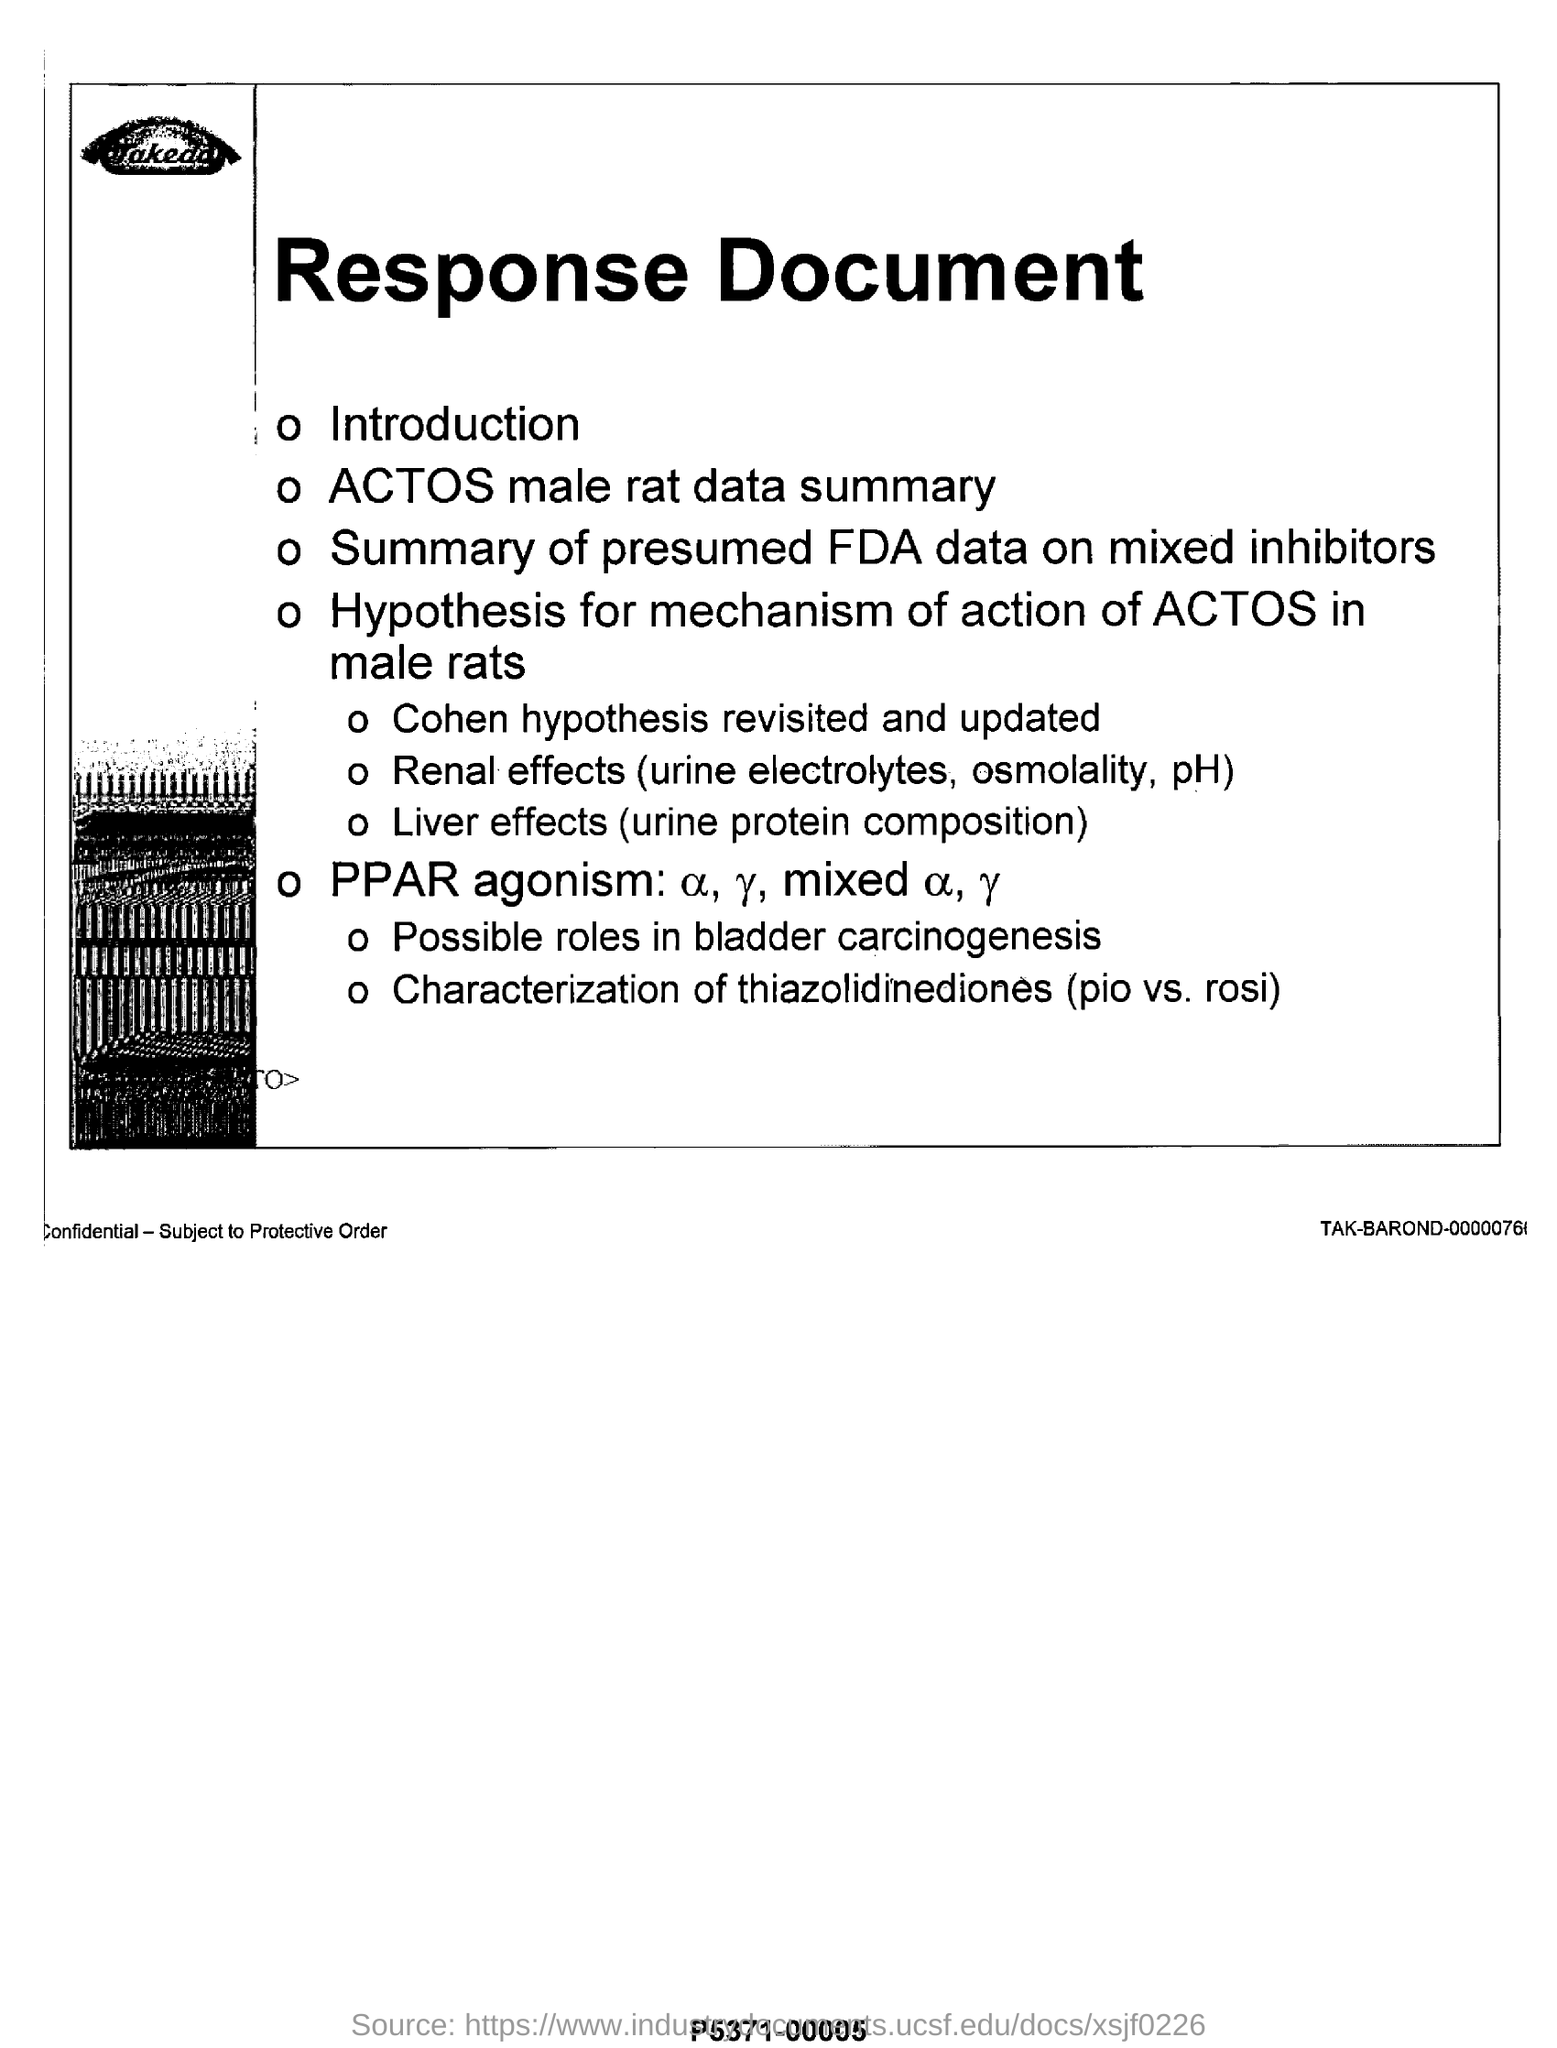Draw attention to some important aspects in this diagram. The heading of the document is 'Response Document'. The renal effects mentioned include urine electrolytes, osmolality, and pH. 